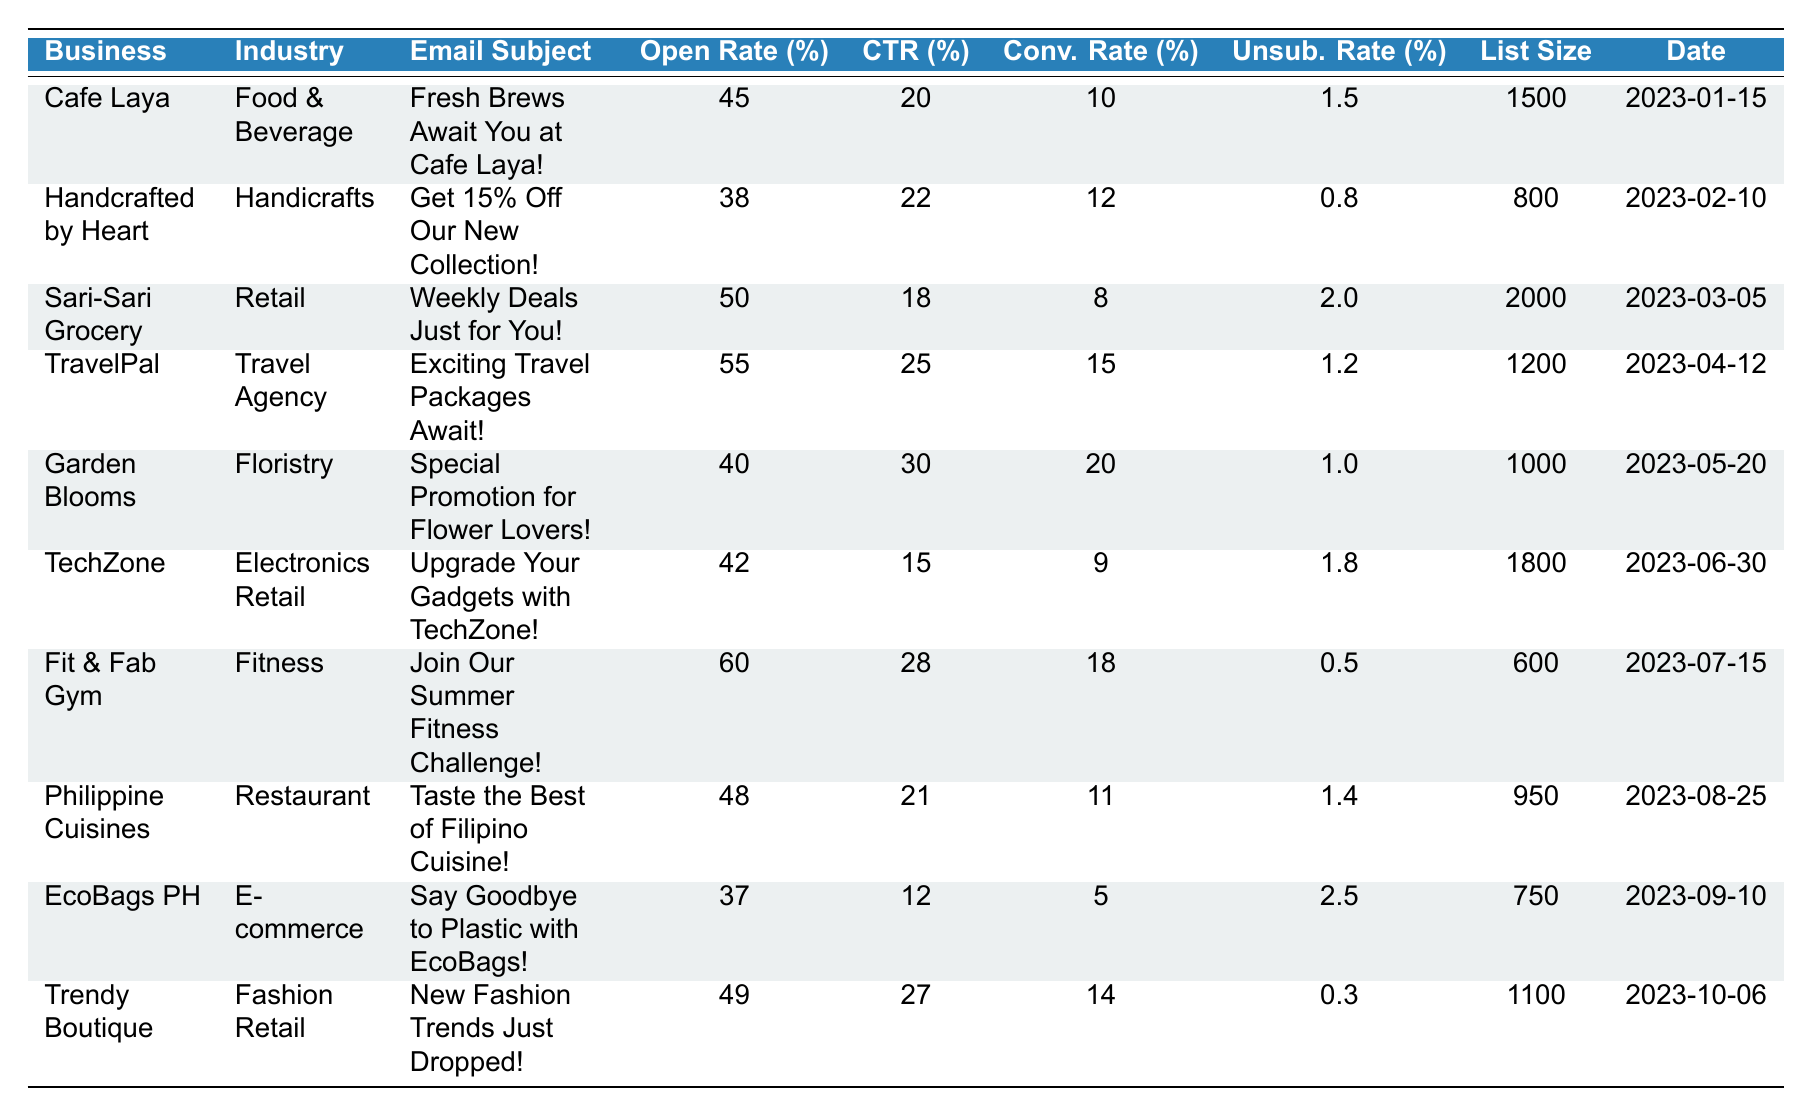What is the open rate for Cafe Laya? The open rate for Cafe Laya is listed as 45% in the table's row corresponding to this business.
Answer: 45% Which business had the highest click-through rate? By examining the click-through rates in the table, TravelPal has the highest rate at 25%.
Answer: TravelPal What is the average conversion rate for all businesses? To find the average conversion rate, sum the conversion rates: (10 + 12 + 8 + 15 + 20 + 9 + 18 + 11 + 5 + 14) = 112. There are 10 businesses, so the average conversion rate is 112 / 10 = 11.2%.
Answer: 11.2% Is the unsubscribe rate for EcoBags PH higher than 2%? The unsubscribe rate for EcoBags PH is 2.5%, which is higher than 2%.
Answer: Yes What is the total size of the email lists for all businesses? To find the total size, sum the email list sizes: (1500 + 800 + 2000 + 1200 + 1000 + 1800 + 600 + 950 + 750 + 1100) = 10900.
Answer: 10900 Which business has a lower open rate, Handcrafted by Heart or TechZone? Handcrafted by Heart has an open rate of 38%, while TechZone has an open rate of 42%. Therefore, Handcrafted by Heart has a lower open rate.
Answer: Handcrafted by Heart What is the difference between the highest and lowest conversion rates? The highest conversion rate is 20% (Garden Blooms), and the lowest is 5% (EcoBags PH). The difference is 20% - 5% = 15%.
Answer: 15% Which industry had the lowest unsubscribe rate? Looking at the unsubscribe rates, Fit & Fab Gym has the lowest rate at 0.5%.
Answer: Fitness If we combine the click-through rates of Cafe Laya and TravelPal, what is the total? The click-through rate for Cafe Laya is 20% and for TravelPal is 25%. Adding them gives 20% + 25% = 45%.
Answer: 45% Did any business have a conversion rate of 18%? Yes, Fit & Fab Gym has a conversion rate of 18%, as found in its row in the table.
Answer: Yes 